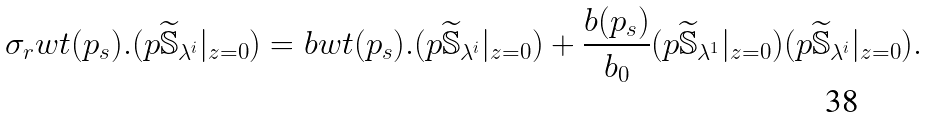<formula> <loc_0><loc_0><loc_500><loc_500>\sigma _ { r } w t ( p _ { s } ) . ( p \widetilde { \mathbb { S } } _ { \lambda ^ { i } } | _ { z = 0 } ) = { b } w t ( p _ { s } ) . ( p \widetilde { \mathbb { S } } _ { \lambda ^ { i } } | _ { z = 0 } ) + \frac { { b } ( p _ { s } ) } { b _ { 0 } } ( p \widetilde { \mathbb { S } } _ { \lambda ^ { 1 } } | _ { z = 0 } ) ( p \widetilde { \mathbb { S } } _ { \lambda ^ { i } } | _ { z = 0 } ) .</formula> 